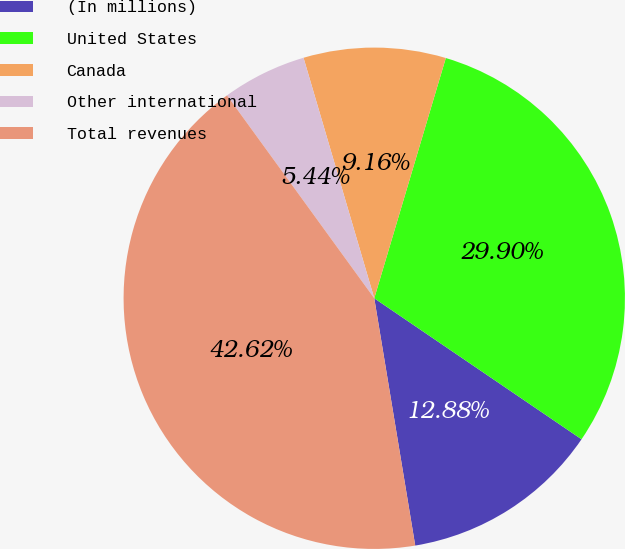Convert chart. <chart><loc_0><loc_0><loc_500><loc_500><pie_chart><fcel>(In millions)<fcel>United States<fcel>Canada<fcel>Other international<fcel>Total revenues<nl><fcel>12.88%<fcel>29.9%<fcel>9.16%<fcel>5.44%<fcel>42.62%<nl></chart> 